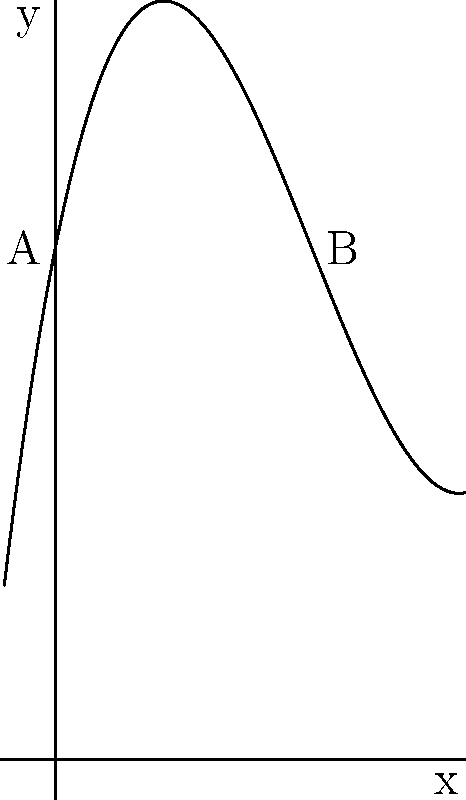The curvature of a golf course fairway is modeled by the polynomial function $f(x) = 0.1x^3 - 1.5x^2 + 5x + 10$, where $x$ is the distance from the tee in hundreds of yards and $f(x)$ is the height of the fairway in feet. If you're standing at point A (the tee) and your golfing buddy is at point B (500 yards away), what's the difference in elevation between you and your buddy? Let's approach this step-by-step:

1) We need to find the height at two points: A (0 yards from tee) and B (500 yards from tee).

2) For point A:
   $x = 0$ (0 yards from tee)
   $f(0) = 0.1(0)^3 - 1.5(0)^2 + 5(0) + 10 = 10$ feet

3) For point B:
   $x = 5$ (500 yards = 5 hundred yards)
   $f(5) = 0.1(5)^3 - 1.5(5)^2 + 5(5) + 10$
         $= 0.1(125) - 1.5(25) + 25 + 10$
         $= 12.5 - 37.5 + 25 + 10 = 10$ feet

4) The difference in elevation:
   $|f(5) - f(0)| = |10 - 10| = 0$ feet

Therefore, there is no difference in elevation between you and your buddy.
Answer: 0 feet 